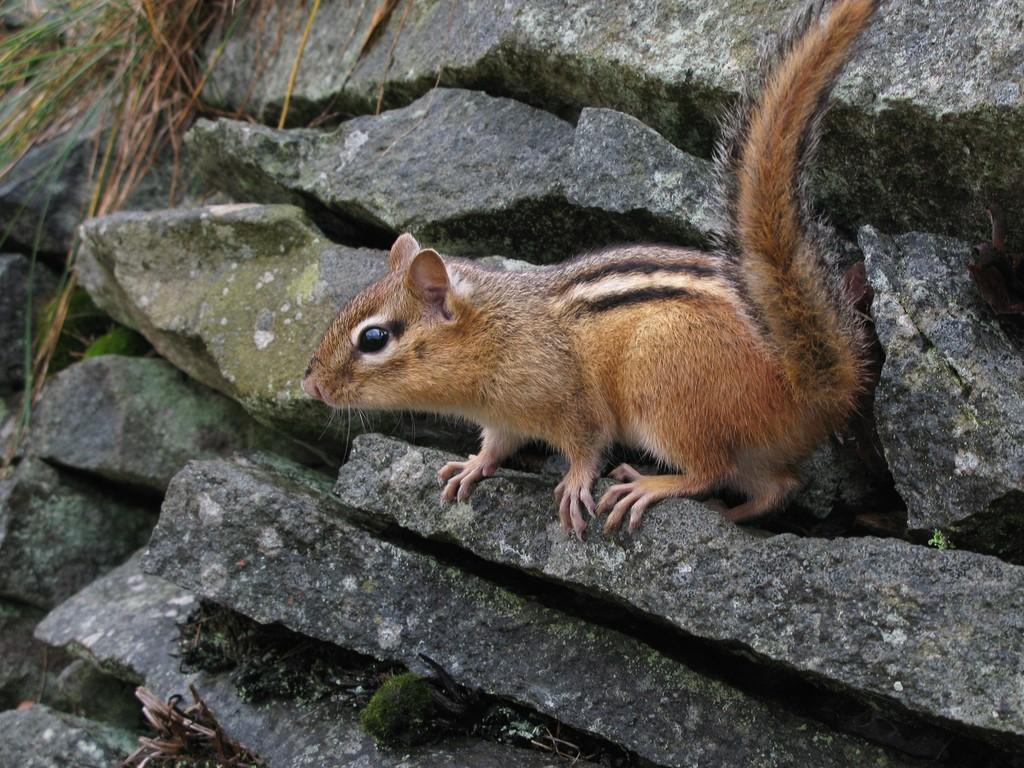What type of animal is in the image? There is a squirrel in the image. What color is the squirrel? The squirrel is brown in color. What is the squirrel standing on? The squirrel is standing on a rock. Are there any other rocks near the squirrel? Yes, there are other rocks beside the squirrel. What type of government does the squirrel represent in the image? The image does not depict any form of government, and the squirrel is not representing any government. 